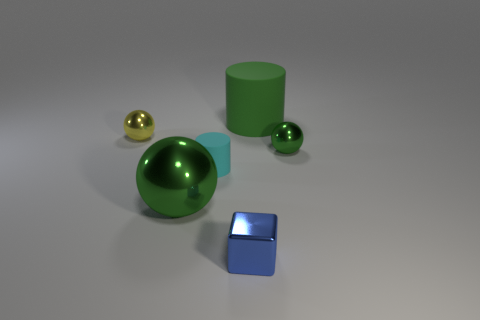Add 1 green shiny spheres. How many objects exist? 7 Subtract all cylinders. How many objects are left? 4 Add 4 blue shiny blocks. How many blue shiny blocks are left? 5 Add 3 tiny red rubber cubes. How many tiny red rubber cubes exist? 3 Subtract 0 cyan cubes. How many objects are left? 6 Subtract all small blue shiny objects. Subtract all small spheres. How many objects are left? 3 